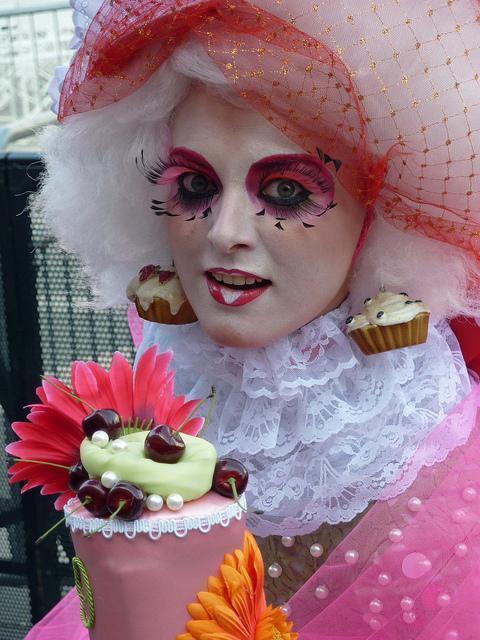What stuff in the photo is edible?
Pick the right solution, then justify: 'Answer: answer
Rationale: rationale.'
Options: White pearl, muffin, flower, cherry. Answer: cherry.
Rationale: The cherries look to be real. 